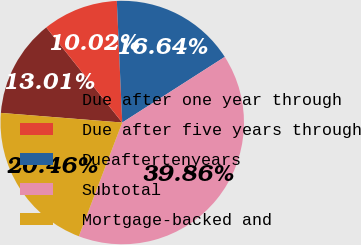<chart> <loc_0><loc_0><loc_500><loc_500><pie_chart><fcel>Due after one year through<fcel>Due after five years through<fcel>Dueaftertenyears<fcel>Subtotal<fcel>Mortgage-backed and<nl><fcel>13.01%<fcel>10.02%<fcel>16.64%<fcel>39.86%<fcel>20.46%<nl></chart> 